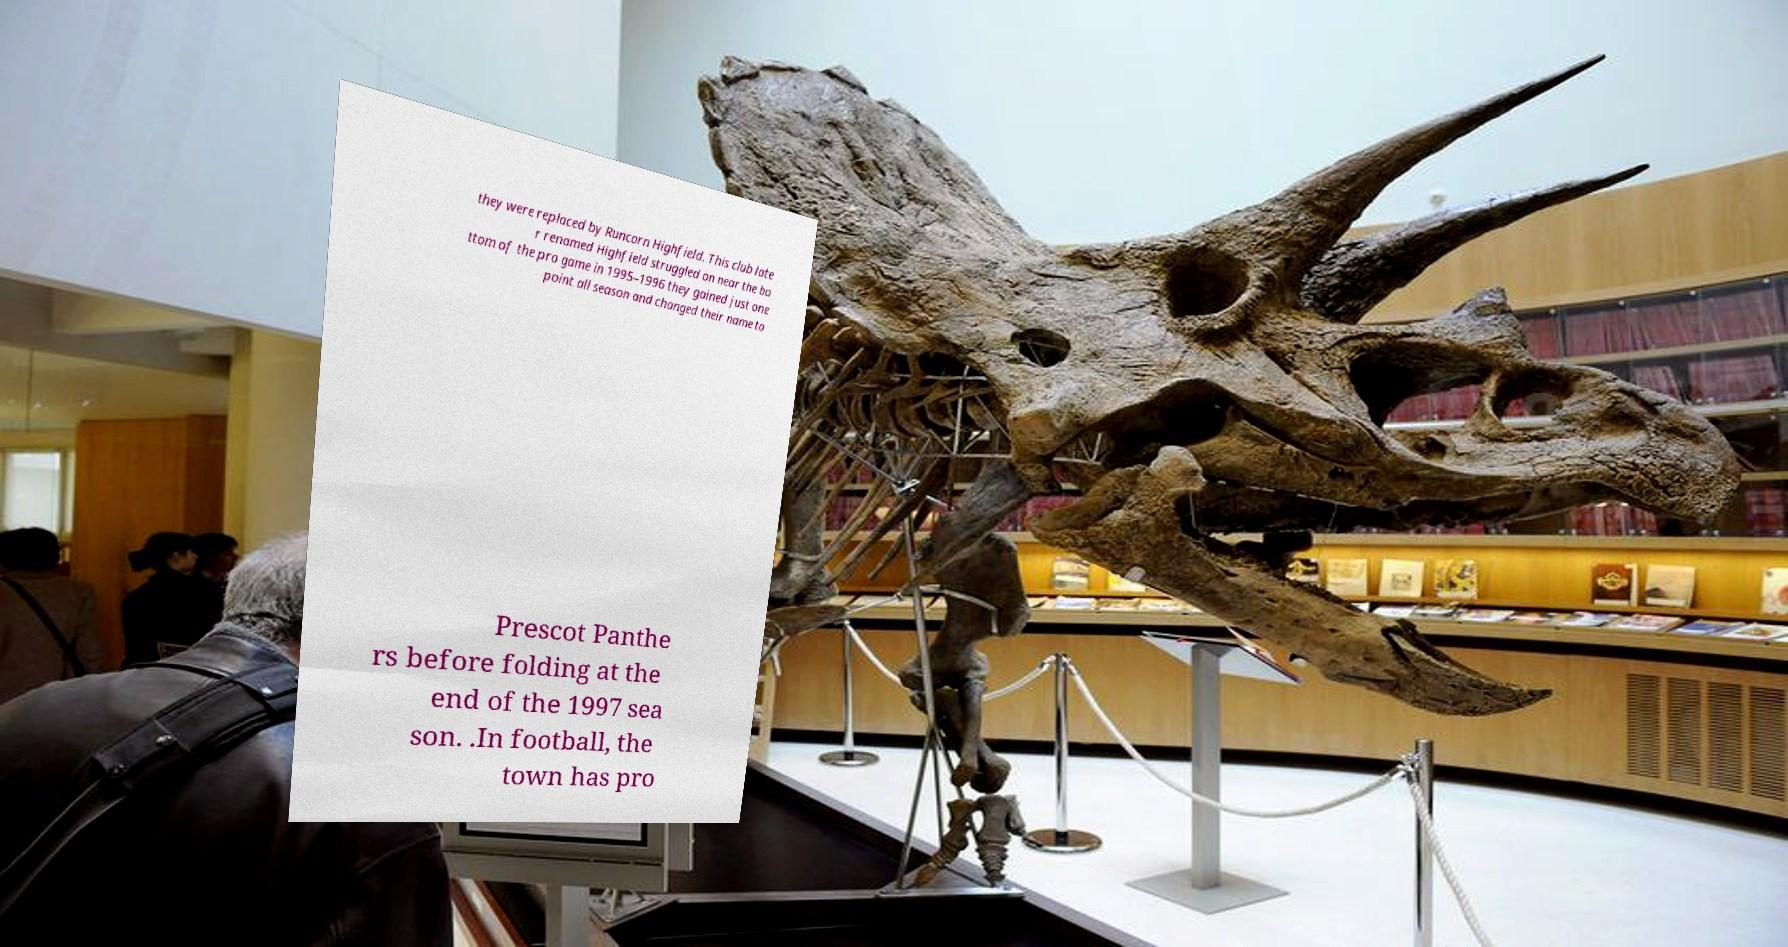Could you assist in decoding the text presented in this image and type it out clearly? they were replaced by Runcorn Highfield. This club late r renamed Highfield struggled on near the bo ttom of the pro game in 1995–1996 they gained just one point all season and changed their name to Prescot Panthe rs before folding at the end of the 1997 sea son. .In football, the town has pro 